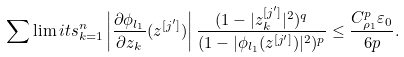Convert formula to latex. <formula><loc_0><loc_0><loc_500><loc_500>\sum \lim i t s ^ { n } _ { k = 1 } \left | \frac { \partial \phi _ { l _ { 1 } } } { \partial z _ { k } } ( z ^ { [ j ^ { \prime } ] } ) \right | \frac { ( 1 - | z ^ { [ j ^ { \prime } ] } _ { k } | ^ { 2 } ) ^ { q } } { ( 1 - | \phi _ { l _ { 1 } } ( z ^ { [ j ^ { \prime } ] } ) | ^ { 2 } ) ^ { p } } \leq \frac { C _ { \rho _ { 1 } } ^ { p } \varepsilon _ { 0 } } { 6 p } .</formula> 